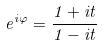Convert formula to latex. <formula><loc_0><loc_0><loc_500><loc_500>e ^ { i \varphi } = \frac { 1 + i t } { 1 - i t }</formula> 